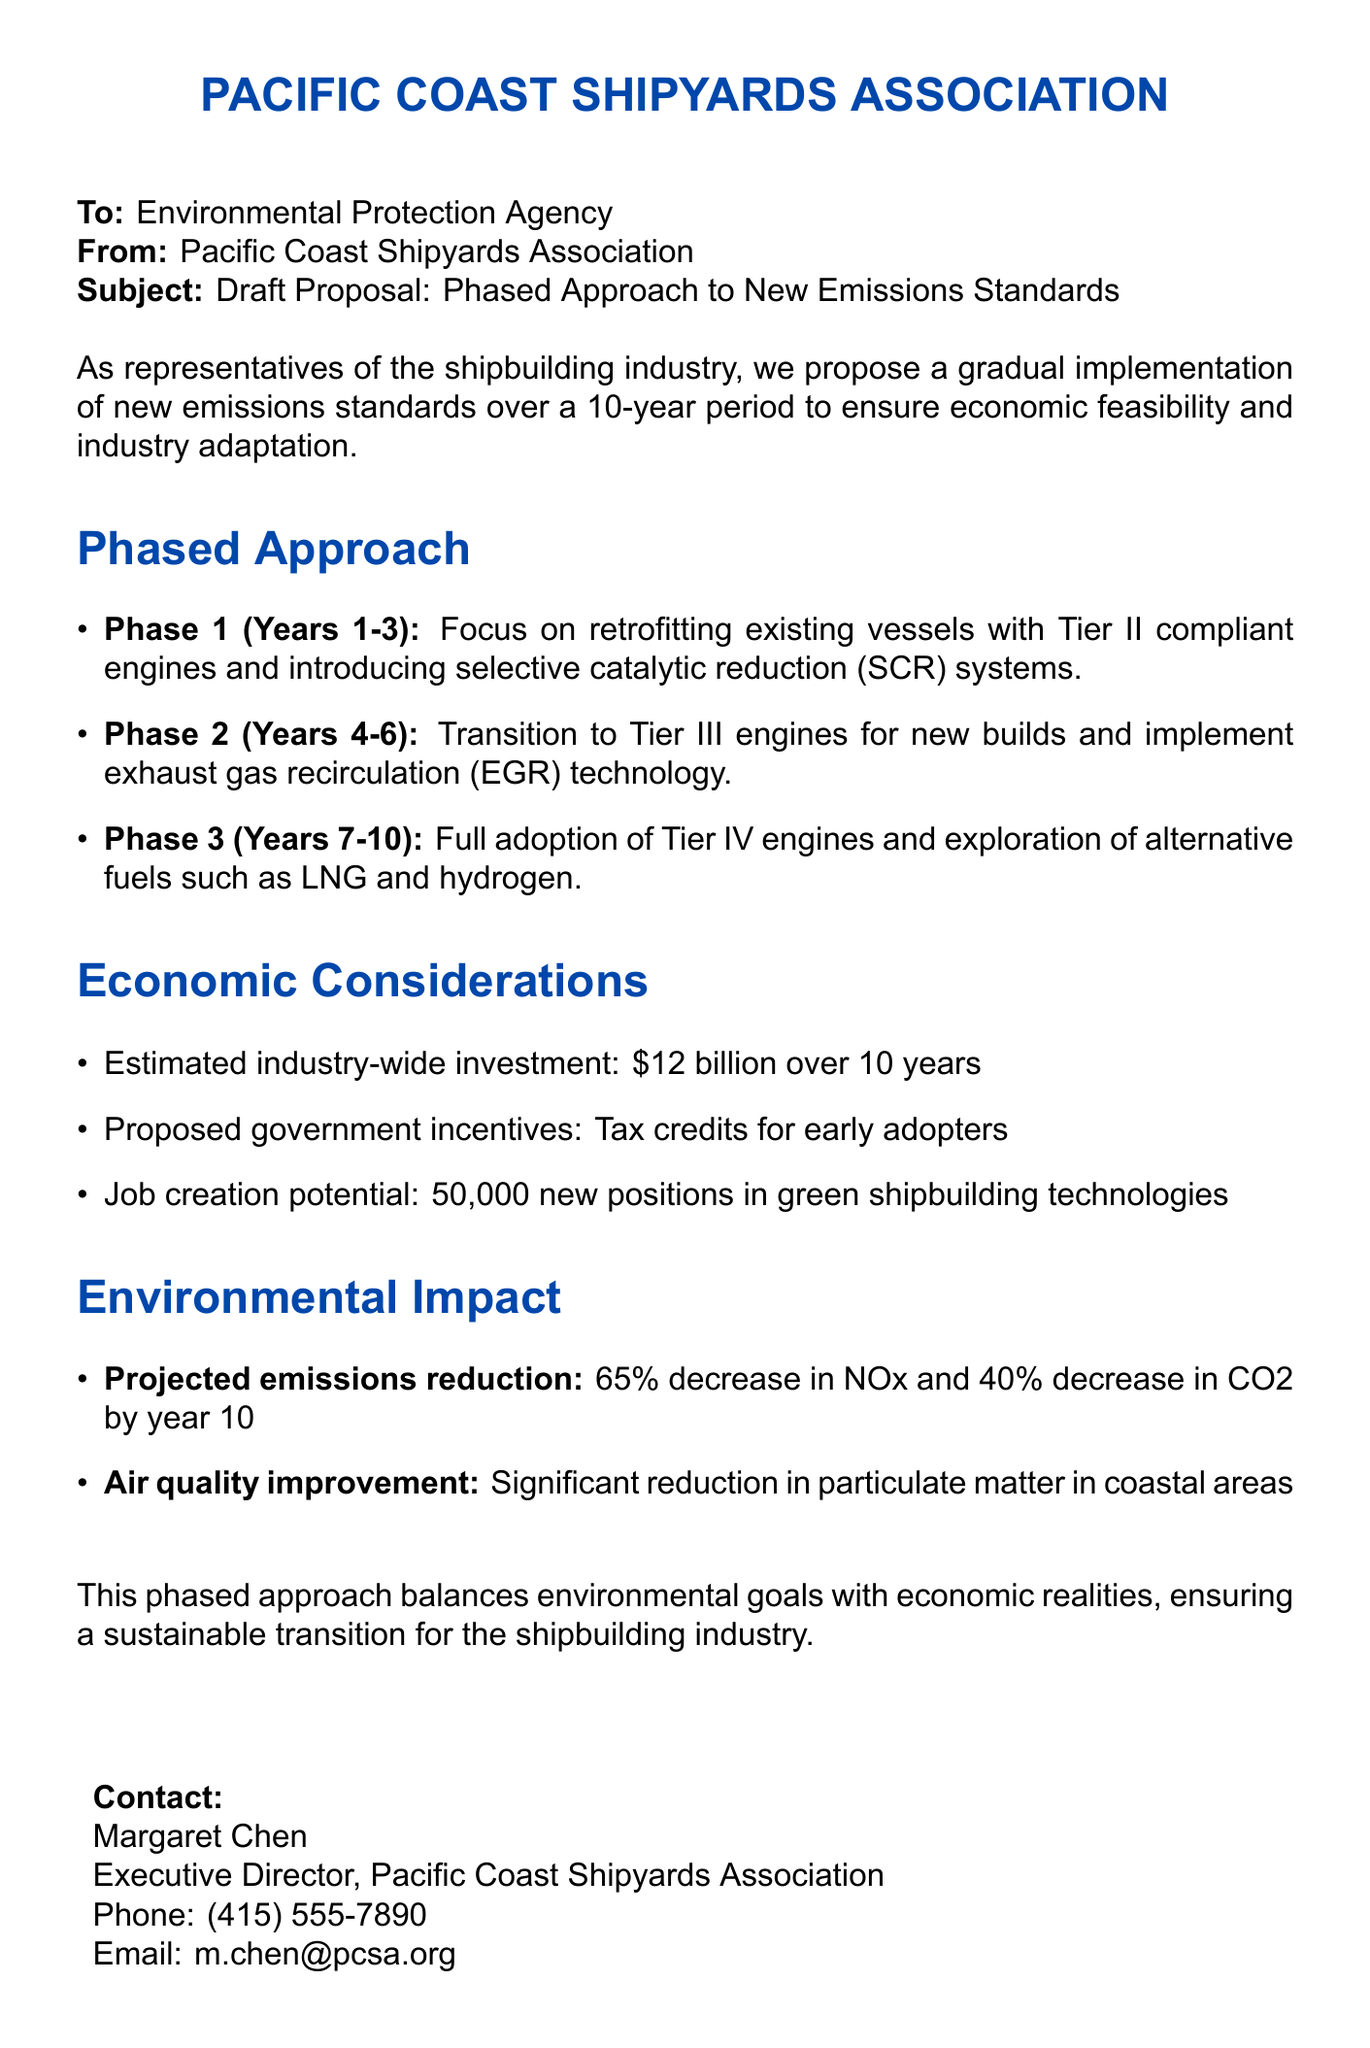What is the title of the document? The title of the document is provided at the top, indicating the subject matter.
Answer: Draft Proposal: Phased Approach to New Emissions Standards What are the three phases of the proposed approach? The document lists the phases of implementation, detailing each phase separately.
Answer: Phase 1, Phase 2, Phase 3 How much is the estimated industry-wide investment? The document provides specific financial details regarding the overall investment necessary for implementation.
Answer: $12 billion What is the job creation potential mentioned in the document? The document outlines the expected impact on employment due to the implementation of the proposal.
Answer: 50,000 new positions What is the projected decrease in NOx emissions after 10 years? The document provides a specific numerical target for emissions reduction.
Answer: 65% What is the focus of Phase 1 in the plan? The document describes the initial focus of the phased approach in detail.
Answer: Retrofitting existing vessels with Tier II compliant engines What type of government support is proposed for early adopters? The document mentions incentives intended to encourage industry compliance with the new standards.
Answer: Tax credits Who is the contact person mentioned in the document? The document lists the contact for further inquiries regarding the proposal.
Answer: Margaret Chen What technology is suggested for new builds in Phase 2? The document specifies the required technology during the second phase of implementation.
Answer: Tier III engines 